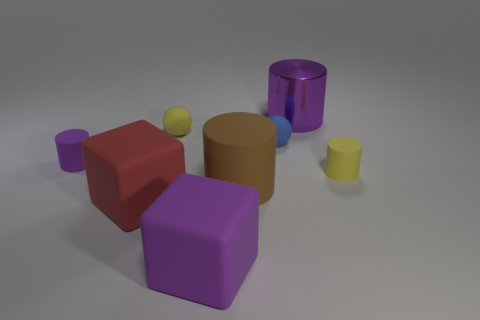Add 1 red cubes. How many objects exist? 9 Subtract all cubes. How many objects are left? 6 Subtract all tiny blue matte objects. Subtract all big cyan rubber things. How many objects are left? 7 Add 5 big rubber blocks. How many big rubber blocks are left? 7 Add 7 red cubes. How many red cubes exist? 8 Subtract 1 blue balls. How many objects are left? 7 